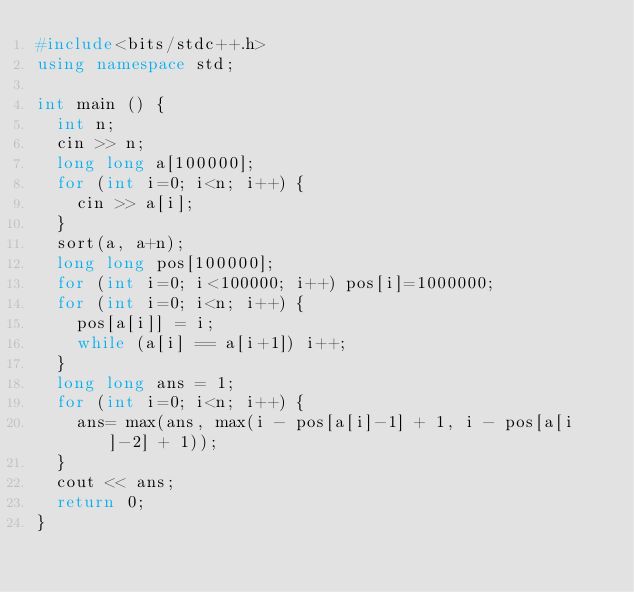<code> <loc_0><loc_0><loc_500><loc_500><_C++_>#include<bits/stdc++.h>
using namespace std;

int main () {
	int n;
	cin >> n;
	long long a[100000];
	for (int i=0; i<n; i++) {
		cin >> a[i];
	}
	sort(a, a+n);
	long long pos[100000];
	for (int i=0; i<100000; i++) pos[i]=1000000;
	for (int i=0; i<n; i++) {
		pos[a[i]] = i;
		while (a[i] == a[i+1]) i++;
	}
	long long ans = 1;
	for (int i=0; i<n; i++) {
		ans= max(ans, max(i - pos[a[i]-1] + 1, i - pos[a[i]-2] + 1));
	}
	cout << ans;
	return 0;
}</code> 